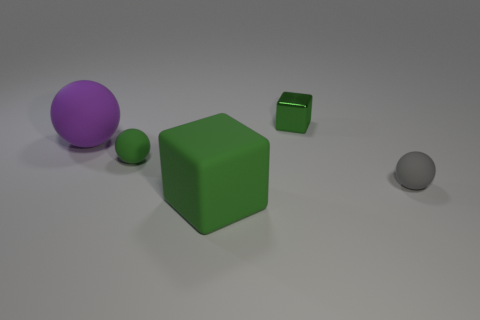What is the size of the other cube that is the same color as the rubber cube?
Provide a succinct answer. Small. There is a big cube that is the same color as the small block; what is it made of?
Your answer should be compact. Rubber. What material is the green object that is both on the left side of the small metallic object and behind the green rubber cube?
Ensure brevity in your answer.  Rubber. The small metal cube is what color?
Ensure brevity in your answer.  Green. What number of small rubber objects are the same shape as the big purple rubber thing?
Make the answer very short. 2. Does the green cube in front of the big sphere have the same material as the small ball that is to the left of the gray ball?
Offer a very short reply. Yes. There is a rubber object that is right of the block that is in front of the purple rubber object; how big is it?
Your response must be concise. Small. Is there anything else that is the same size as the green shiny thing?
Your answer should be very brief. Yes. What material is the gray thing that is the same shape as the large purple thing?
Keep it short and to the point. Rubber. Does the tiny green object in front of the tiny metal object have the same shape as the small thing behind the purple ball?
Your response must be concise. No. 